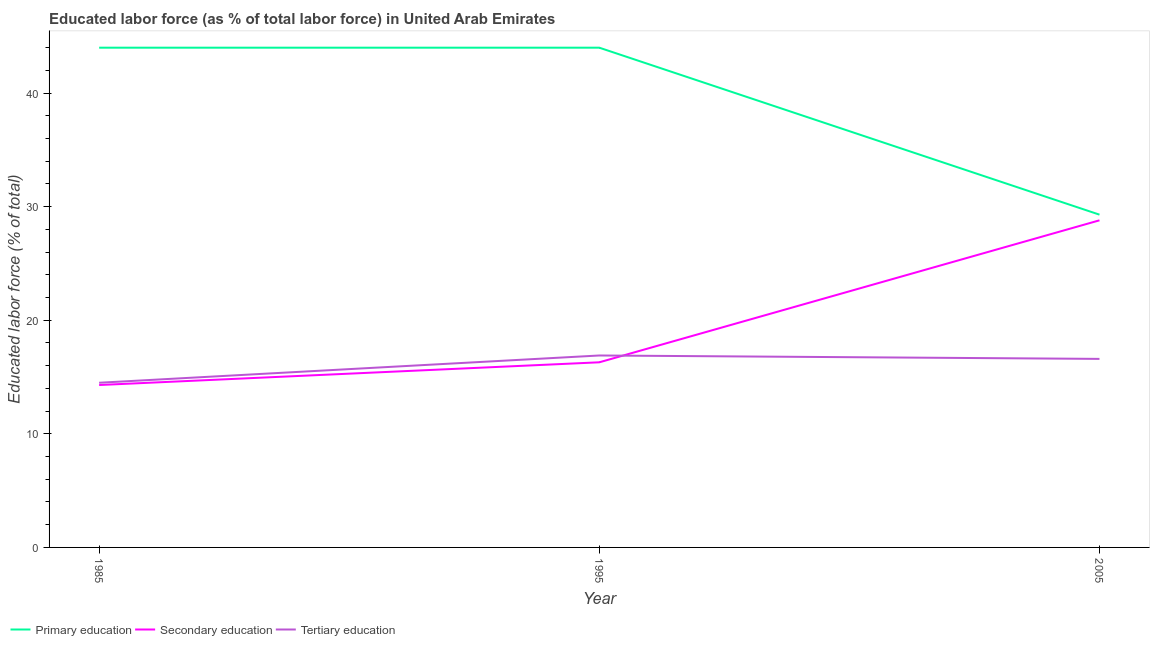How many different coloured lines are there?
Provide a short and direct response. 3. Is the number of lines equal to the number of legend labels?
Provide a succinct answer. Yes. Across all years, what is the maximum percentage of labor force who received secondary education?
Keep it short and to the point. 28.8. In which year was the percentage of labor force who received tertiary education maximum?
Provide a short and direct response. 1995. In which year was the percentage of labor force who received tertiary education minimum?
Give a very brief answer. 1985. What is the total percentage of labor force who received tertiary education in the graph?
Give a very brief answer. 48. What is the difference between the percentage of labor force who received secondary education in 1985 and that in 2005?
Make the answer very short. -14.5. What is the difference between the percentage of labor force who received tertiary education in 1995 and the percentage of labor force who received secondary education in 2005?
Offer a terse response. -11.9. What is the average percentage of labor force who received primary education per year?
Offer a very short reply. 39.1. In the year 2005, what is the difference between the percentage of labor force who received tertiary education and percentage of labor force who received secondary education?
Provide a succinct answer. -12.2. In how many years, is the percentage of labor force who received secondary education greater than 24 %?
Provide a short and direct response. 1. What is the ratio of the percentage of labor force who received primary education in 1995 to that in 2005?
Your answer should be very brief. 1.5. Is the difference between the percentage of labor force who received tertiary education in 1985 and 1995 greater than the difference between the percentage of labor force who received primary education in 1985 and 1995?
Offer a terse response. No. What is the difference between the highest and the second highest percentage of labor force who received tertiary education?
Offer a very short reply. 0.3. What is the difference between the highest and the lowest percentage of labor force who received secondary education?
Your answer should be compact. 14.5. Is the sum of the percentage of labor force who received primary education in 1985 and 1995 greater than the maximum percentage of labor force who received tertiary education across all years?
Provide a short and direct response. Yes. Is it the case that in every year, the sum of the percentage of labor force who received primary education and percentage of labor force who received secondary education is greater than the percentage of labor force who received tertiary education?
Make the answer very short. Yes. Is the percentage of labor force who received secondary education strictly less than the percentage of labor force who received primary education over the years?
Your answer should be compact. Yes. How many lines are there?
Provide a succinct answer. 3. How many years are there in the graph?
Make the answer very short. 3. Does the graph contain any zero values?
Your response must be concise. No. Does the graph contain grids?
Your response must be concise. No. What is the title of the graph?
Provide a short and direct response. Educated labor force (as % of total labor force) in United Arab Emirates. Does "Primary education" appear as one of the legend labels in the graph?
Your response must be concise. Yes. What is the label or title of the X-axis?
Make the answer very short. Year. What is the label or title of the Y-axis?
Provide a short and direct response. Educated labor force (% of total). What is the Educated labor force (% of total) in Secondary education in 1985?
Your answer should be very brief. 14.3. What is the Educated labor force (% of total) in Secondary education in 1995?
Your answer should be very brief. 16.3. What is the Educated labor force (% of total) of Tertiary education in 1995?
Offer a terse response. 16.9. What is the Educated labor force (% of total) in Primary education in 2005?
Offer a terse response. 29.3. What is the Educated labor force (% of total) in Secondary education in 2005?
Your response must be concise. 28.8. What is the Educated labor force (% of total) in Tertiary education in 2005?
Your answer should be compact. 16.6. Across all years, what is the maximum Educated labor force (% of total) in Secondary education?
Offer a terse response. 28.8. Across all years, what is the maximum Educated labor force (% of total) in Tertiary education?
Give a very brief answer. 16.9. Across all years, what is the minimum Educated labor force (% of total) in Primary education?
Your response must be concise. 29.3. Across all years, what is the minimum Educated labor force (% of total) in Secondary education?
Make the answer very short. 14.3. Across all years, what is the minimum Educated labor force (% of total) in Tertiary education?
Offer a very short reply. 14.5. What is the total Educated labor force (% of total) in Primary education in the graph?
Ensure brevity in your answer.  117.3. What is the total Educated labor force (% of total) in Secondary education in the graph?
Provide a succinct answer. 59.4. What is the total Educated labor force (% of total) of Tertiary education in the graph?
Your response must be concise. 48. What is the difference between the Educated labor force (% of total) in Primary education in 1985 and that in 1995?
Your answer should be very brief. 0. What is the difference between the Educated labor force (% of total) of Secondary education in 1985 and that in 1995?
Ensure brevity in your answer.  -2. What is the difference between the Educated labor force (% of total) in Secondary education in 1985 and that in 2005?
Ensure brevity in your answer.  -14.5. What is the difference between the Educated labor force (% of total) in Tertiary education in 1985 and that in 2005?
Your answer should be very brief. -2.1. What is the difference between the Educated labor force (% of total) in Primary education in 1985 and the Educated labor force (% of total) in Secondary education in 1995?
Make the answer very short. 27.7. What is the difference between the Educated labor force (% of total) in Primary education in 1985 and the Educated labor force (% of total) in Tertiary education in 1995?
Keep it short and to the point. 27.1. What is the difference between the Educated labor force (% of total) of Secondary education in 1985 and the Educated labor force (% of total) of Tertiary education in 1995?
Give a very brief answer. -2.6. What is the difference between the Educated labor force (% of total) of Primary education in 1985 and the Educated labor force (% of total) of Secondary education in 2005?
Your answer should be very brief. 15.2. What is the difference between the Educated labor force (% of total) of Primary education in 1985 and the Educated labor force (% of total) of Tertiary education in 2005?
Offer a very short reply. 27.4. What is the difference between the Educated labor force (% of total) of Secondary education in 1985 and the Educated labor force (% of total) of Tertiary education in 2005?
Your response must be concise. -2.3. What is the difference between the Educated labor force (% of total) in Primary education in 1995 and the Educated labor force (% of total) in Secondary education in 2005?
Your answer should be compact. 15.2. What is the difference between the Educated labor force (% of total) in Primary education in 1995 and the Educated labor force (% of total) in Tertiary education in 2005?
Your response must be concise. 27.4. What is the difference between the Educated labor force (% of total) in Secondary education in 1995 and the Educated labor force (% of total) in Tertiary education in 2005?
Ensure brevity in your answer.  -0.3. What is the average Educated labor force (% of total) in Primary education per year?
Offer a very short reply. 39.1. What is the average Educated labor force (% of total) of Secondary education per year?
Offer a very short reply. 19.8. What is the average Educated labor force (% of total) in Tertiary education per year?
Offer a very short reply. 16. In the year 1985, what is the difference between the Educated labor force (% of total) in Primary education and Educated labor force (% of total) in Secondary education?
Your answer should be very brief. 29.7. In the year 1985, what is the difference between the Educated labor force (% of total) of Primary education and Educated labor force (% of total) of Tertiary education?
Keep it short and to the point. 29.5. In the year 1985, what is the difference between the Educated labor force (% of total) of Secondary education and Educated labor force (% of total) of Tertiary education?
Your answer should be very brief. -0.2. In the year 1995, what is the difference between the Educated labor force (% of total) in Primary education and Educated labor force (% of total) in Secondary education?
Provide a succinct answer. 27.7. In the year 1995, what is the difference between the Educated labor force (% of total) in Primary education and Educated labor force (% of total) in Tertiary education?
Provide a short and direct response. 27.1. In the year 2005, what is the difference between the Educated labor force (% of total) in Primary education and Educated labor force (% of total) in Tertiary education?
Your answer should be very brief. 12.7. In the year 2005, what is the difference between the Educated labor force (% of total) in Secondary education and Educated labor force (% of total) in Tertiary education?
Provide a succinct answer. 12.2. What is the ratio of the Educated labor force (% of total) of Secondary education in 1985 to that in 1995?
Your answer should be compact. 0.88. What is the ratio of the Educated labor force (% of total) of Tertiary education in 1985 to that in 1995?
Keep it short and to the point. 0.86. What is the ratio of the Educated labor force (% of total) in Primary education in 1985 to that in 2005?
Keep it short and to the point. 1.5. What is the ratio of the Educated labor force (% of total) of Secondary education in 1985 to that in 2005?
Your response must be concise. 0.5. What is the ratio of the Educated labor force (% of total) in Tertiary education in 1985 to that in 2005?
Give a very brief answer. 0.87. What is the ratio of the Educated labor force (% of total) in Primary education in 1995 to that in 2005?
Provide a short and direct response. 1.5. What is the ratio of the Educated labor force (% of total) in Secondary education in 1995 to that in 2005?
Ensure brevity in your answer.  0.57. What is the ratio of the Educated labor force (% of total) in Tertiary education in 1995 to that in 2005?
Keep it short and to the point. 1.02. What is the difference between the highest and the second highest Educated labor force (% of total) in Primary education?
Your answer should be very brief. 0. What is the difference between the highest and the second highest Educated labor force (% of total) of Tertiary education?
Make the answer very short. 0.3. What is the difference between the highest and the lowest Educated labor force (% of total) of Tertiary education?
Offer a terse response. 2.4. 